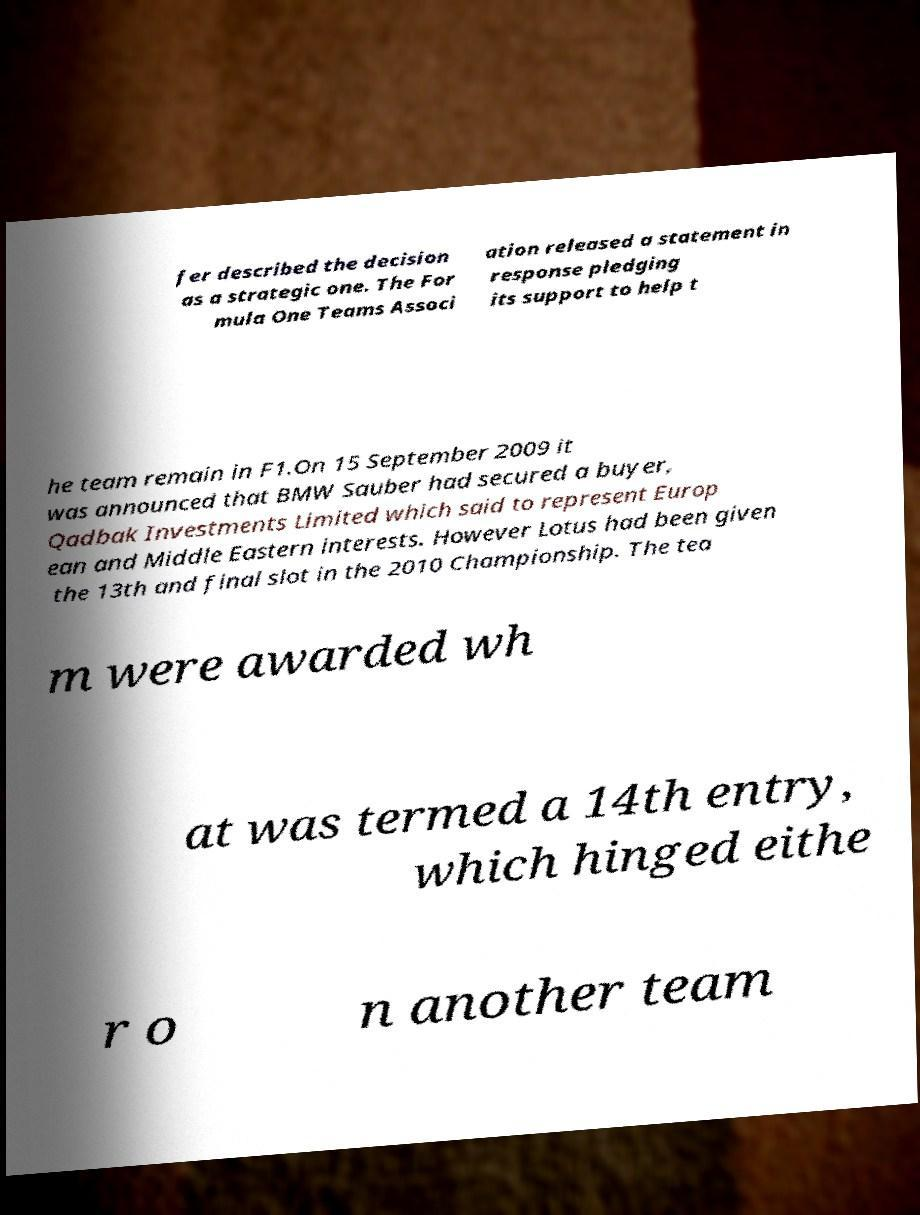Could you assist in decoding the text presented in this image and type it out clearly? fer described the decision as a strategic one. The For mula One Teams Associ ation released a statement in response pledging its support to help t he team remain in F1.On 15 September 2009 it was announced that BMW Sauber had secured a buyer, Qadbak Investments Limited which said to represent Europ ean and Middle Eastern interests. However Lotus had been given the 13th and final slot in the 2010 Championship. The tea m were awarded wh at was termed a 14th entry, which hinged eithe r o n another team 